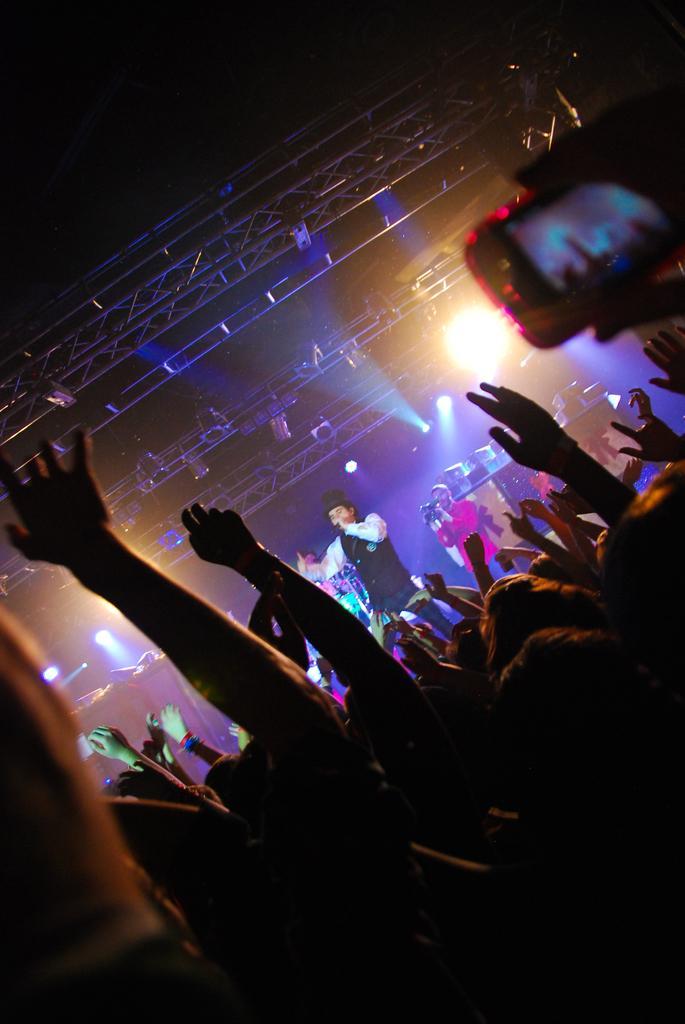Can you describe this image briefly? Here we can see crowd and there is a person singing on the mike. There is a person holding a camera. In the background we can see lights. 